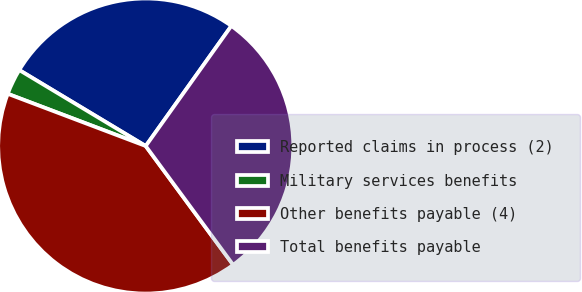<chart> <loc_0><loc_0><loc_500><loc_500><pie_chart><fcel>Reported claims in process (2)<fcel>Military services benefits<fcel>Other benefits payable (4)<fcel>Total benefits payable<nl><fcel>26.25%<fcel>2.85%<fcel>40.86%<fcel>30.05%<nl></chart> 